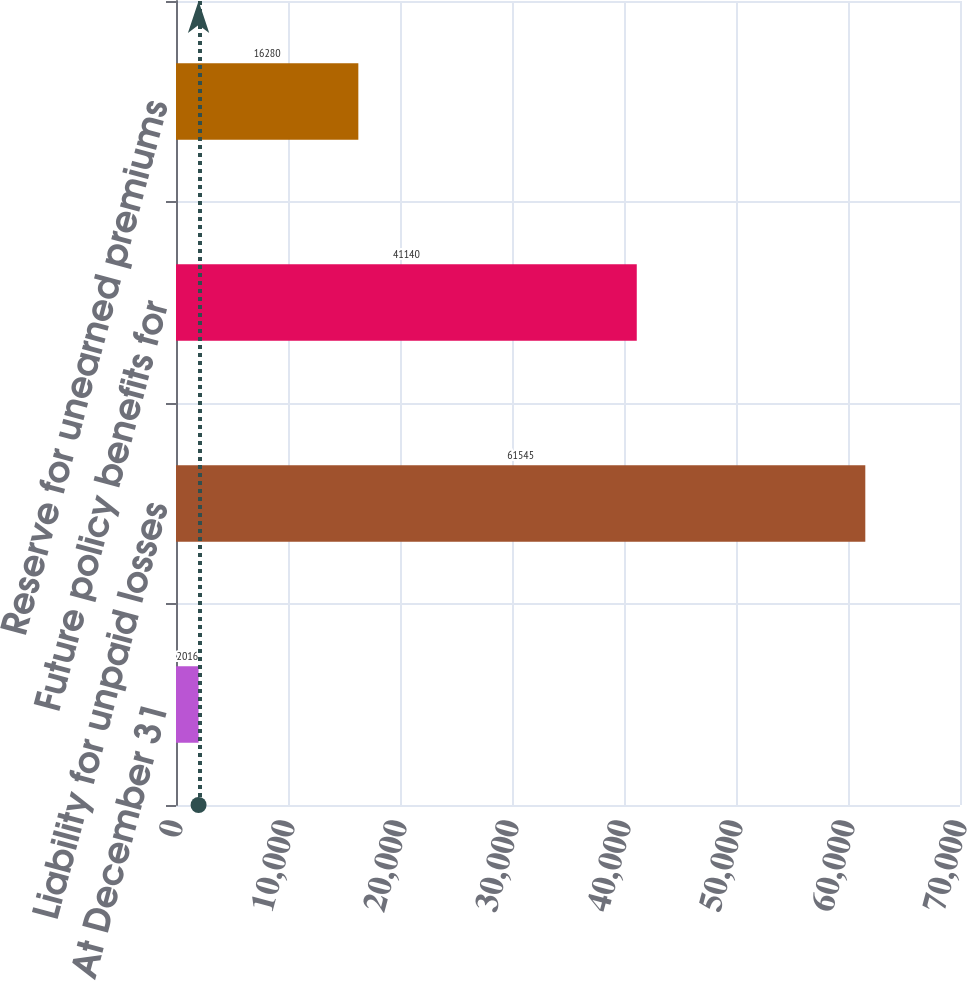Convert chart to OTSL. <chart><loc_0><loc_0><loc_500><loc_500><bar_chart><fcel>At December 31<fcel>Liability for unpaid losses<fcel>Future policy benefits for<fcel>Reserve for unearned premiums<nl><fcel>2016<fcel>61545<fcel>41140<fcel>16280<nl></chart> 